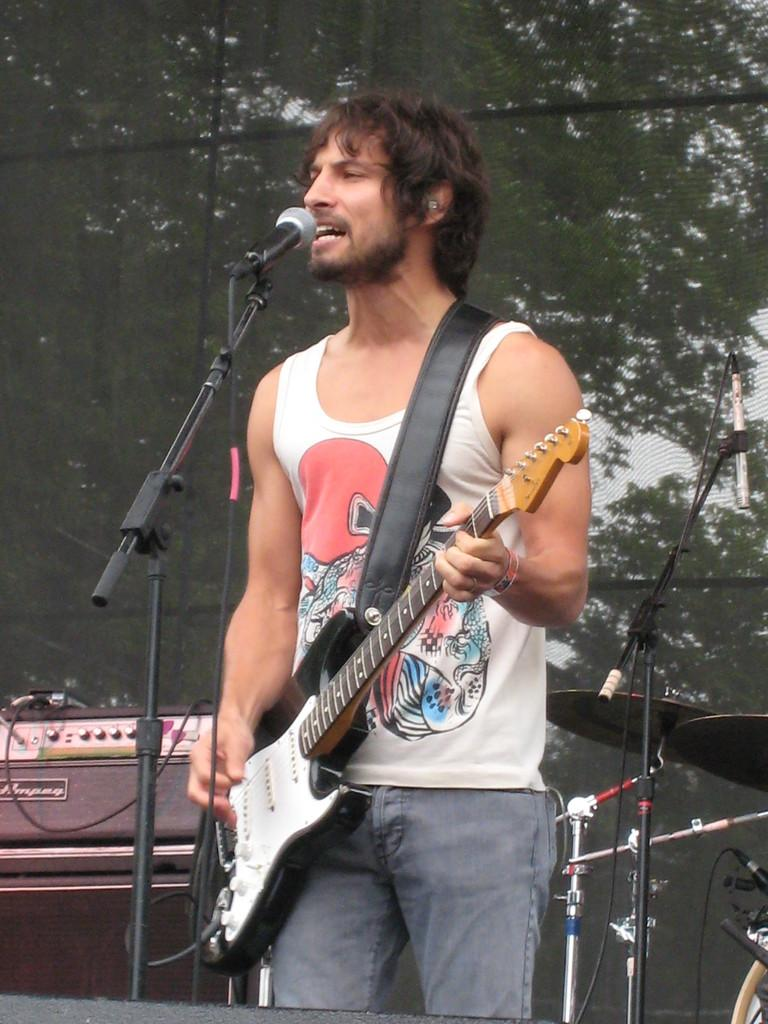What is the person in the image doing? The person is playing a guitar. What is the person wearing in the image? The person is wearing a white T-shirt. What object is in front of the person? There is a microphone in front of the person. What can be seen in the background of the image? There are trees in the background of the image. What type of lunch is being prepared in the image? There is no indication of lunch preparation in the image; it features a person playing a guitar with a microphone in front of them and trees in the background. 